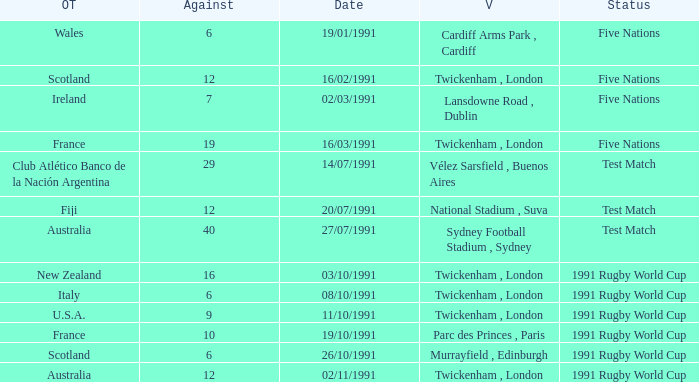Could you parse the entire table as a dict? {'header': ['OT', 'Against', 'Date', 'V', 'Status'], 'rows': [['Wales', '6', '19/01/1991', 'Cardiff Arms Park , Cardiff', 'Five Nations'], ['Scotland', '12', '16/02/1991', 'Twickenham , London', 'Five Nations'], ['Ireland', '7', '02/03/1991', 'Lansdowne Road , Dublin', 'Five Nations'], ['France', '19', '16/03/1991', 'Twickenham , London', 'Five Nations'], ['Club Atlético Banco de la Nación Argentina', '29', '14/07/1991', 'Vélez Sarsfield , Buenos Aires', 'Test Match'], ['Fiji', '12', '20/07/1991', 'National Stadium , Suva', 'Test Match'], ['Australia', '40', '27/07/1991', 'Sydney Football Stadium , Sydney', 'Test Match'], ['New Zealand', '16', '03/10/1991', 'Twickenham , London', '1991 Rugby World Cup'], ['Italy', '6', '08/10/1991', 'Twickenham , London', '1991 Rugby World Cup'], ['U.S.A.', '9', '11/10/1991', 'Twickenham , London', '1991 Rugby World Cup'], ['France', '10', '19/10/1991', 'Parc des Princes , Paris', '1991 Rugby World Cup'], ['Scotland', '6', '26/10/1991', 'Murrayfield , Edinburgh', '1991 Rugby World Cup'], ['Australia', '12', '02/11/1991', 'Twickenham , London', '1991 Rugby World Cup']]} What is Against, when Opposing Teams is "Australia", and when Date is "27/07/1991"? 40.0. 